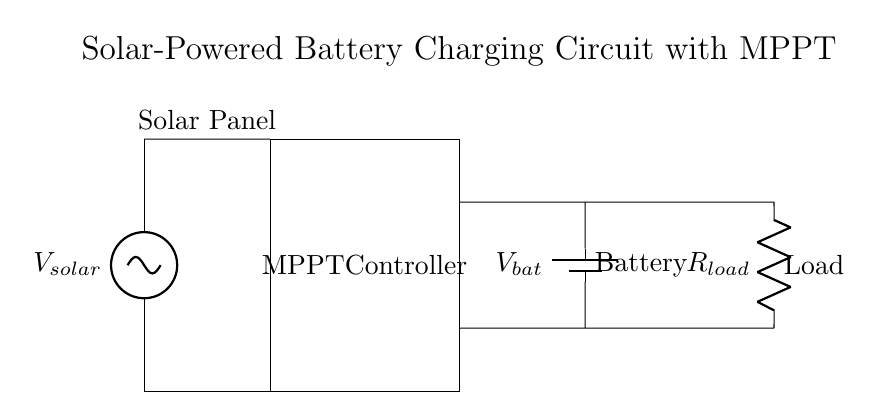What component is used for energy harvesting in this circuit? The component responsible for energy harvesting in this circuit is the solar panel, which converts sunlight into electrical energy.
Answer: Solar Panel What does MPPT stand for? MPPT stands for Maximum Power Point Tracking, a technology that optimizes power extraction from solar panels by adjusting the electrical operating point.
Answer: Maximum Power Point Tracking How many main components are visible in this circuit diagram? The circuit diagram displays three main components: a solar panel, an MPPT controller, a battery, and a load. Adding battery and load makes a total of four distinct components.
Answer: Four What is the role of the battery in this circuit? The battery serves to store the electrical energy generated by the solar panel for later use when the load requires power.
Answer: Store energy How do the solar panel and MPPT controller connect? The solar panel is directly connected to the MPPT controller through short wires (represented by short lines), allowing efficient transfer of generated electrical energy.
Answer: Directly What is the purpose of the load in this circuit? The load represents the device or component that consumes power, utilizing the energy stored in the battery to operate.
Answer: Consume power What type of devices are intended to be powered by this circuit? This circuit is designed for portable electronic devices, such as smartphones, tablets, or small gadgets that require low power consumption.
Answer: Portable electronic devices 